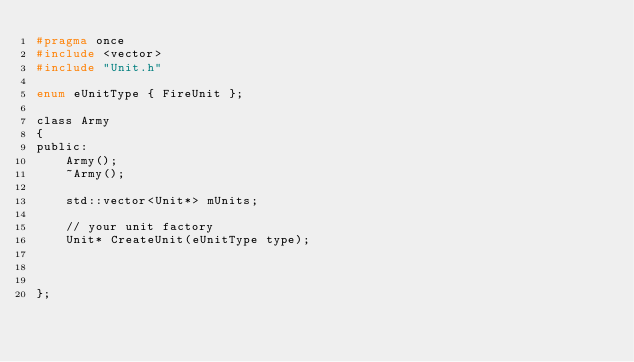Convert code to text. <code><loc_0><loc_0><loc_500><loc_500><_C_>#pragma once
#include <vector>
#include "Unit.h"

enum eUnitType { FireUnit };

class Army
{
public:
	Army();
	~Army();

	std::vector<Unit*> mUnits;

	// your unit factory
	Unit* CreateUnit(eUnitType type);
	
	

};

</code> 